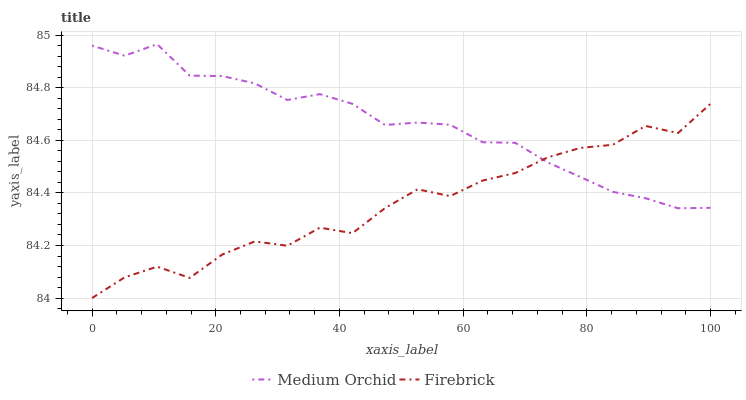Does Firebrick have the minimum area under the curve?
Answer yes or no. Yes. Does Medium Orchid have the maximum area under the curve?
Answer yes or no. Yes. Does Medium Orchid have the minimum area under the curve?
Answer yes or no. No. Is Medium Orchid the smoothest?
Answer yes or no. Yes. Is Firebrick the roughest?
Answer yes or no. Yes. Is Medium Orchid the roughest?
Answer yes or no. No. Does Firebrick have the lowest value?
Answer yes or no. Yes. Does Medium Orchid have the lowest value?
Answer yes or no. No. Does Medium Orchid have the highest value?
Answer yes or no. Yes. Does Firebrick intersect Medium Orchid?
Answer yes or no. Yes. Is Firebrick less than Medium Orchid?
Answer yes or no. No. Is Firebrick greater than Medium Orchid?
Answer yes or no. No. 